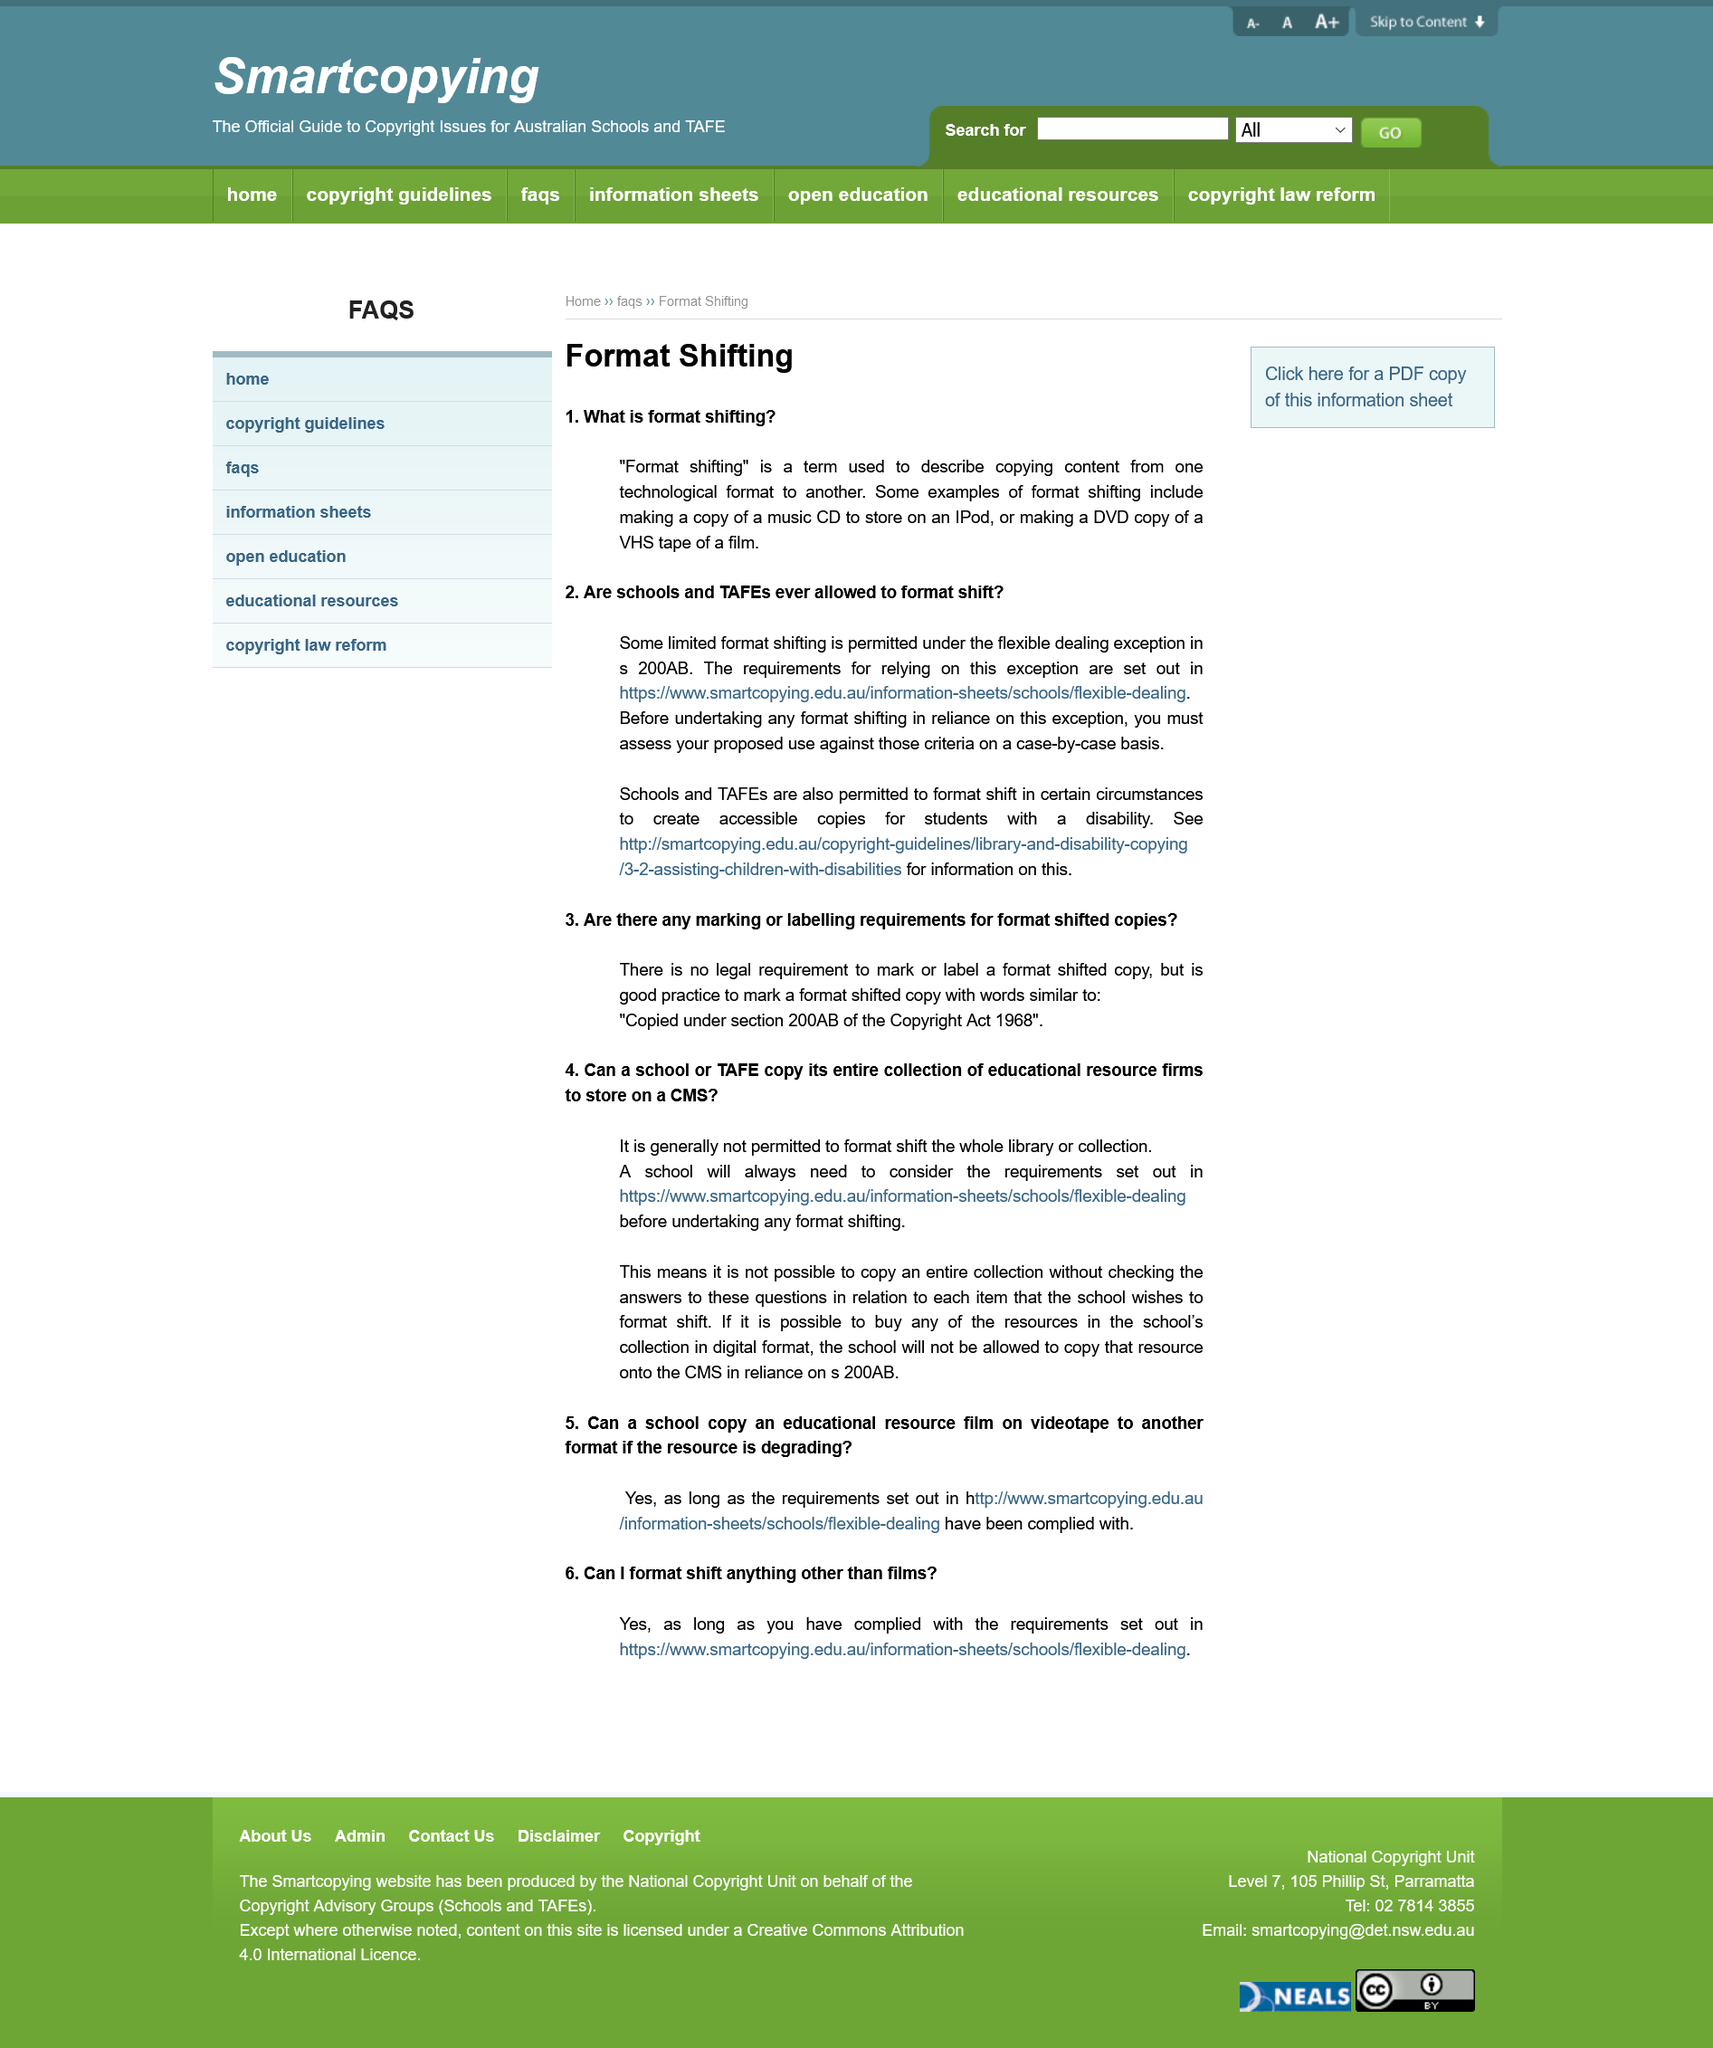Point out several critical features in this image. The requirements for relying on this exception are outlined in <https://www.smartcopying.edu.au/information-sheets/schools/flexible-dealing>. Format shifting refers to the act of making a copy of a digital media file, such as a music CD or a movie DVD, and transferring it to a different device or format for personal use, such as storing it on an iPod or making a DVD copy of a VHS tape. The article refers to schools and TAFE institutes as places of study. Format shifting refers to the act of copying content from one technological format to another, such as from a physical CD to an MP3 player or from a digital file to a different digital format. The hyperlink in the given text is blue in color. 